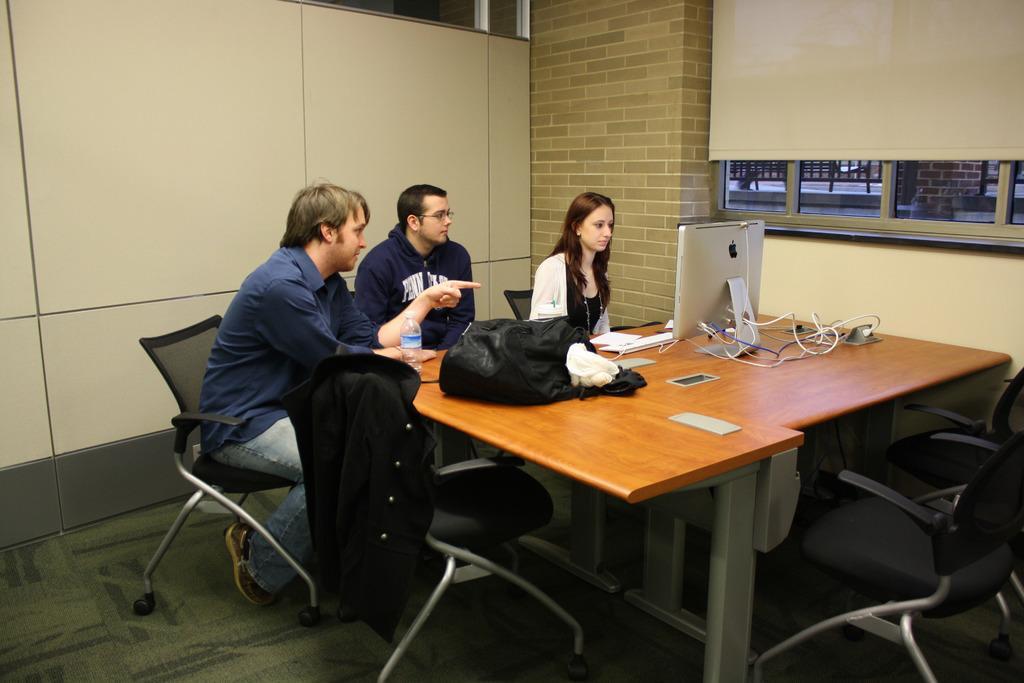Could you give a brief overview of what you see in this image? In the given image we can see there are three persons sitting on a chair. There is a table on which a system is kept. There is a water bottle on a table. 